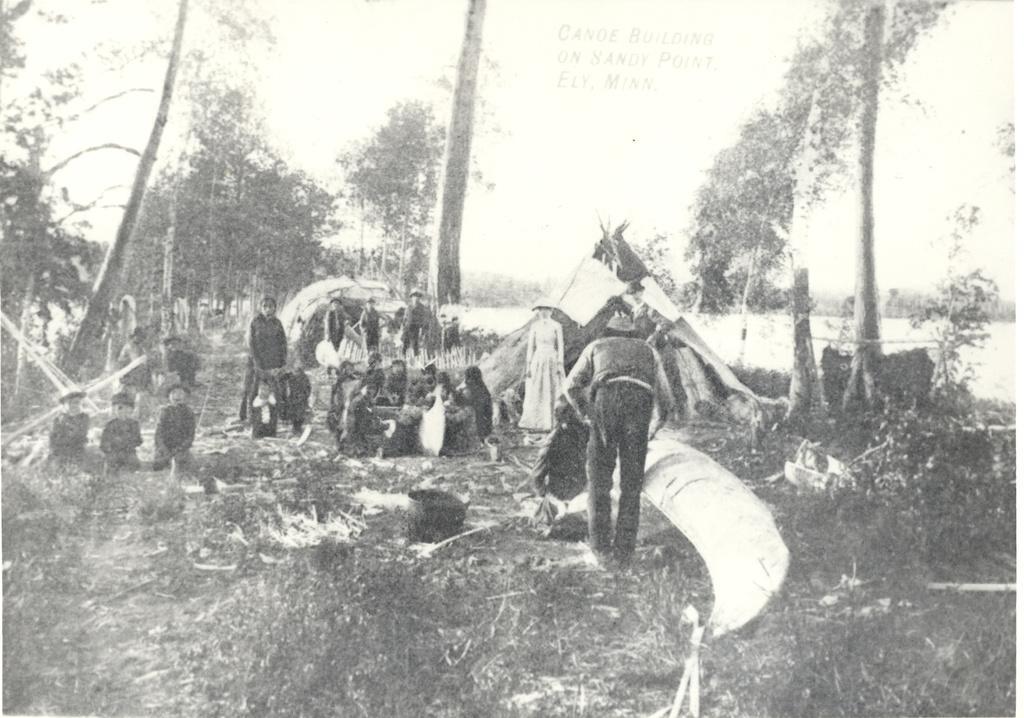Please provide a concise description of this image. In the picture we can see a photograph which is black and white in color and in that we can see some people sitting on the grass surface and some are standing and behind them we can see some trees. 